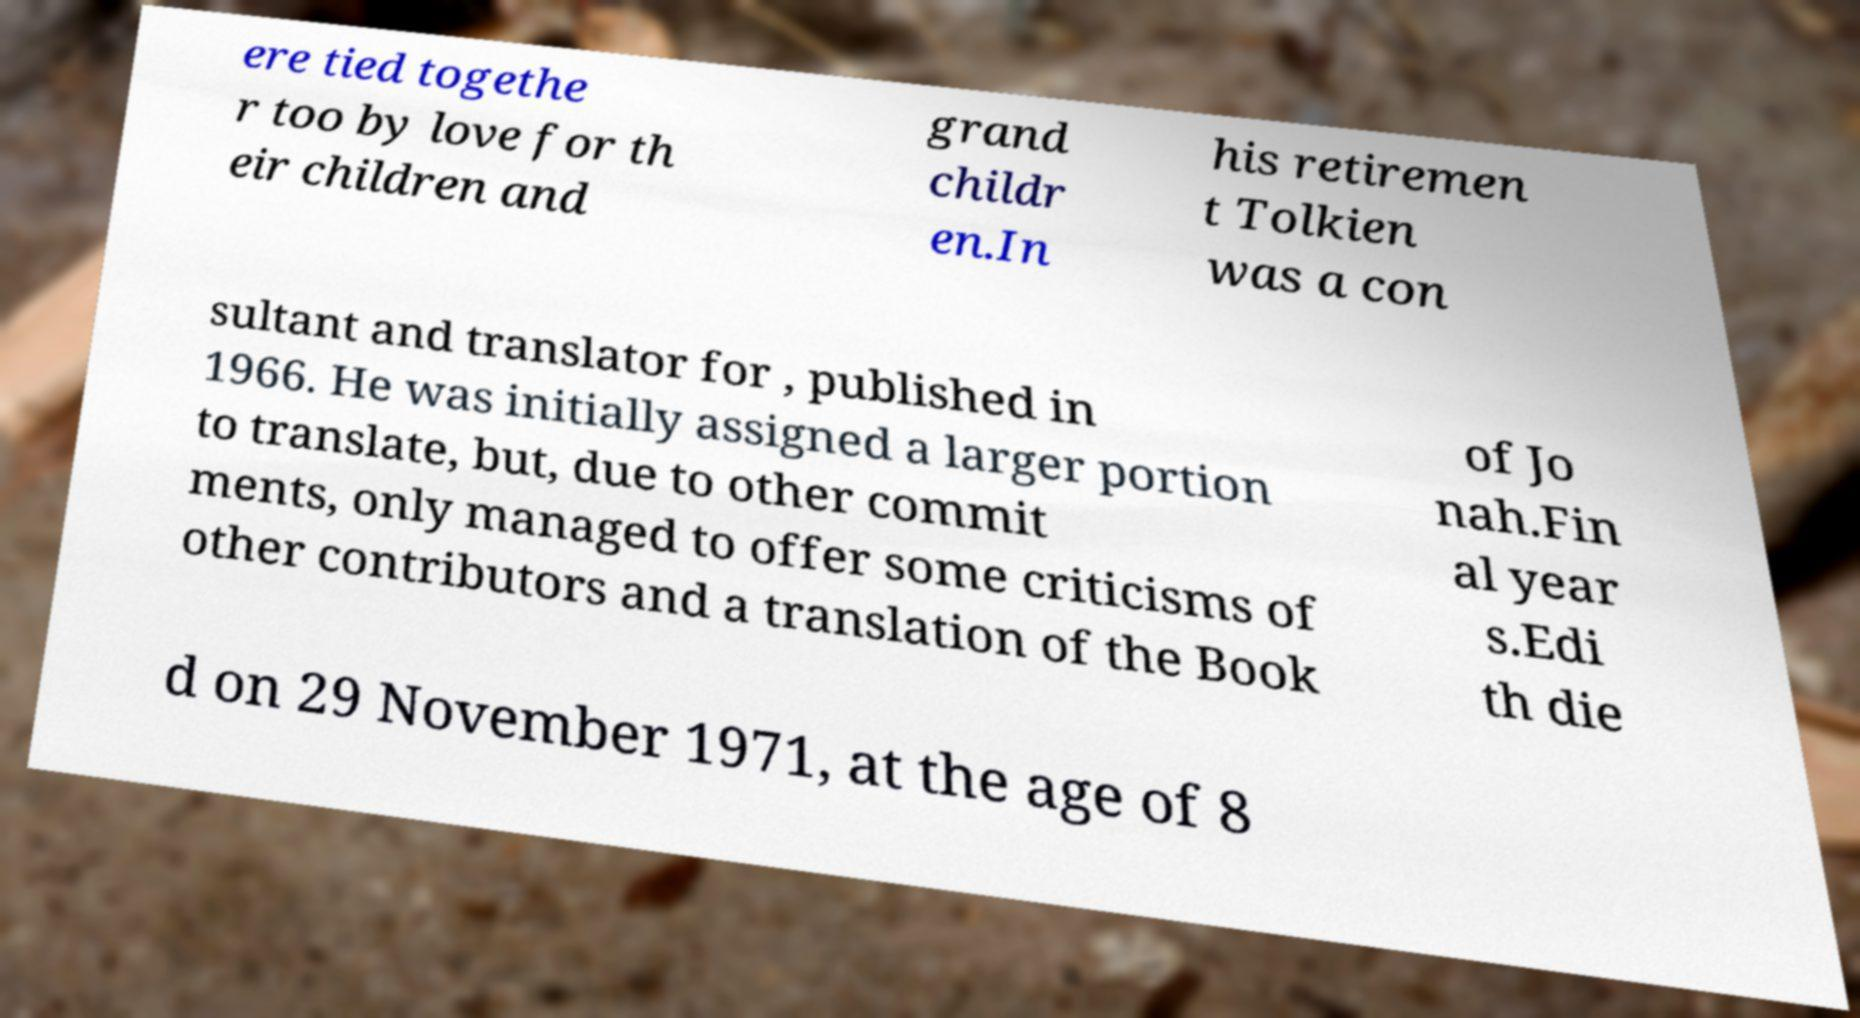Can you accurately transcribe the text from the provided image for me? ere tied togethe r too by love for th eir children and grand childr en.In his retiremen t Tolkien was a con sultant and translator for , published in 1966. He was initially assigned a larger portion to translate, but, due to other commit ments, only managed to offer some criticisms of other contributors and a translation of the Book of Jo nah.Fin al year s.Edi th die d on 29 November 1971, at the age of 8 